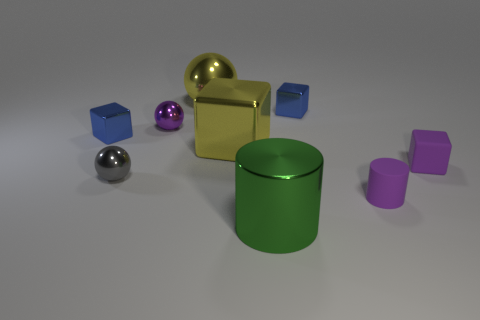What shape is the purple metal object that is the same size as the gray metallic object?
Keep it short and to the point. Sphere. There is a thing that is behind the small blue thing on the right side of the large metallic ball; is there a tiny block that is to the right of it?
Ensure brevity in your answer.  Yes. Is there a blue thing of the same size as the rubber cylinder?
Your response must be concise. Yes. What is the size of the shiny thing in front of the purple cylinder?
Ensure brevity in your answer.  Large. There is a small matte thing that is in front of the tiny rubber cube behind the matte thing that is in front of the gray sphere; what is its color?
Keep it short and to the point. Purple. What is the color of the tiny metallic sphere that is behind the blue shiny thing to the left of the big cylinder?
Your answer should be compact. Purple. Is the number of yellow balls right of the gray metal sphere greater than the number of metallic spheres behind the green cylinder?
Offer a very short reply. No. Do the purple object that is in front of the small purple rubber cube and the cylinder in front of the tiny purple cylinder have the same material?
Keep it short and to the point. No. Are there any purple rubber objects on the left side of the gray shiny object?
Your answer should be very brief. No. What number of blue objects are tiny blocks or metallic cubes?
Your answer should be very brief. 2. 